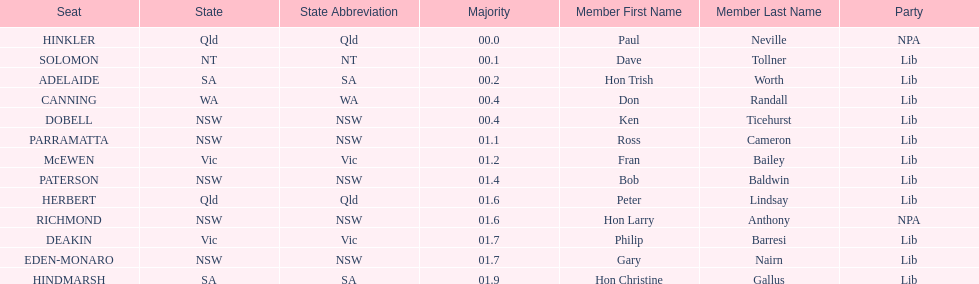What is the name of the last seat? HINDMARSH. 